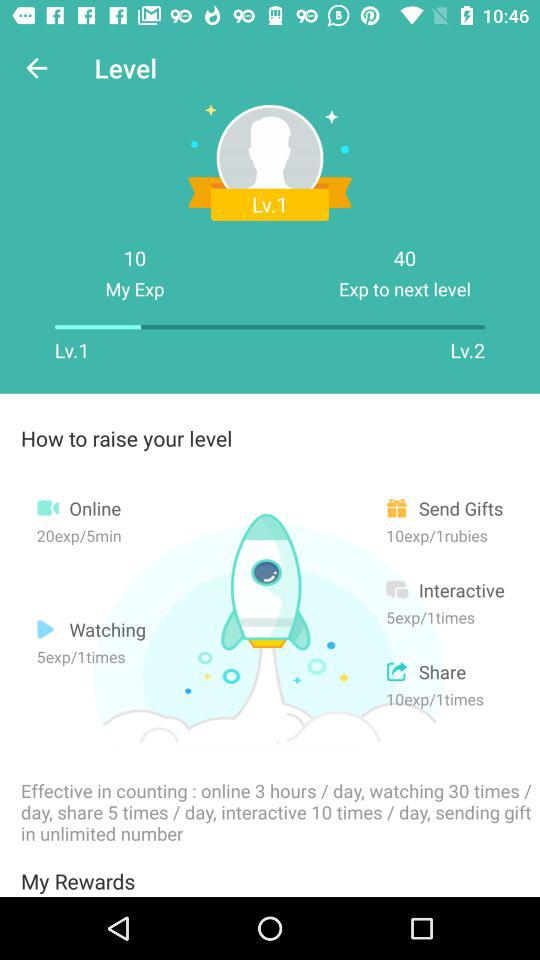How many times can I send gifts per day?
Answer the question using a single word or phrase. Unlimited 